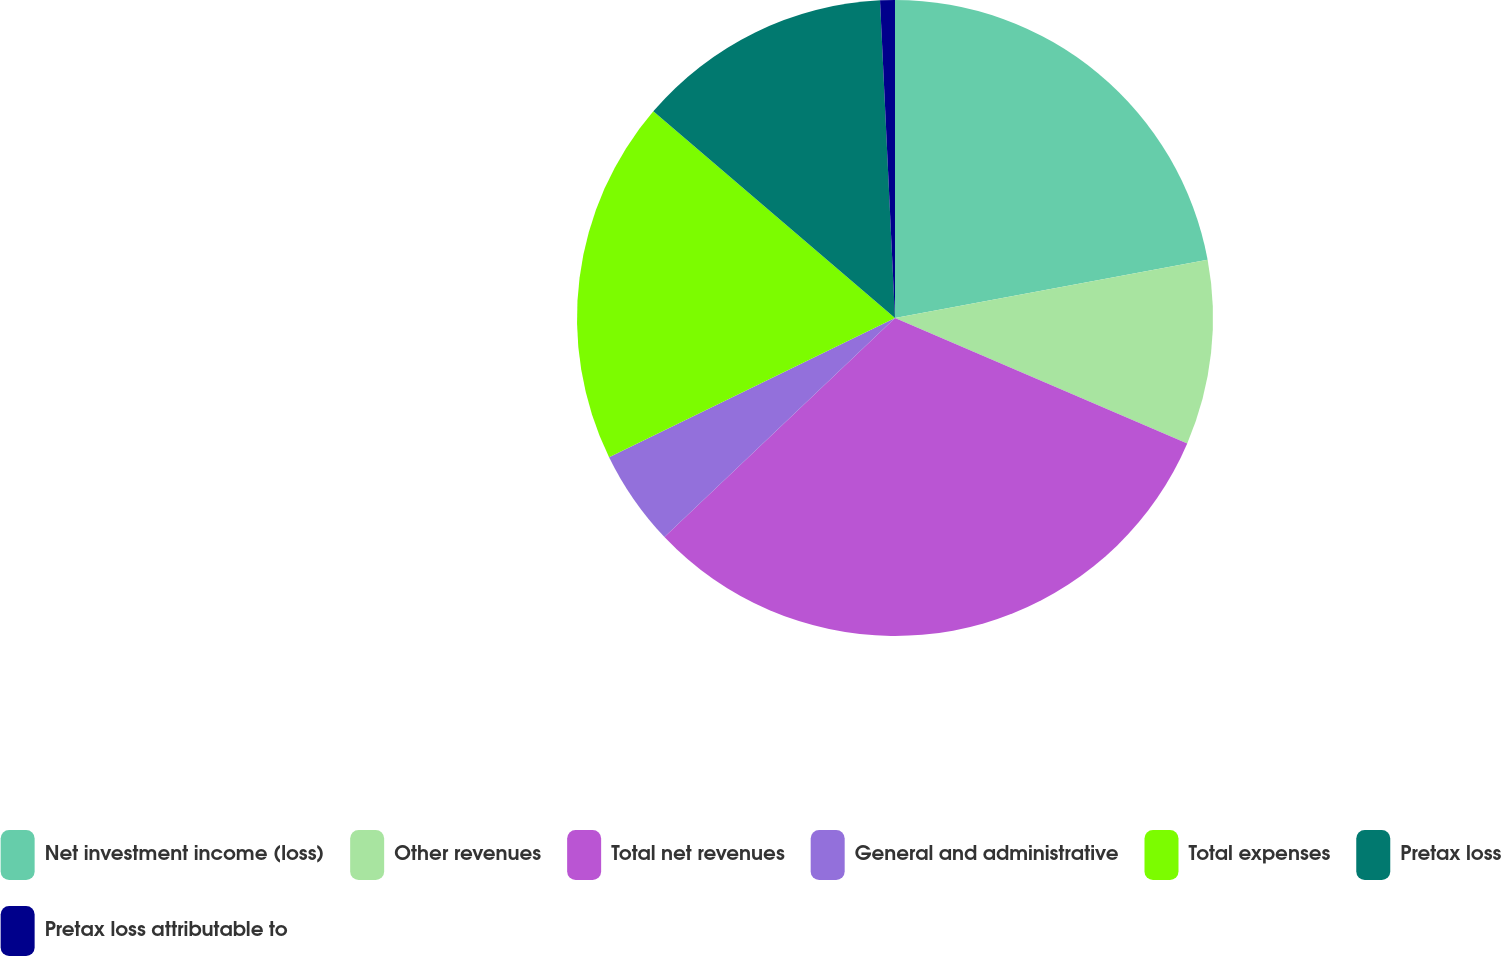Convert chart to OTSL. <chart><loc_0><loc_0><loc_500><loc_500><pie_chart><fcel>Net investment income (loss)<fcel>Other revenues<fcel>Total net revenues<fcel>General and administrative<fcel>Total expenses<fcel>Pretax loss<fcel>Pretax loss attributable to<nl><fcel>22.07%<fcel>9.38%<fcel>31.46%<fcel>4.88%<fcel>18.47%<fcel>12.99%<fcel>0.75%<nl></chart> 